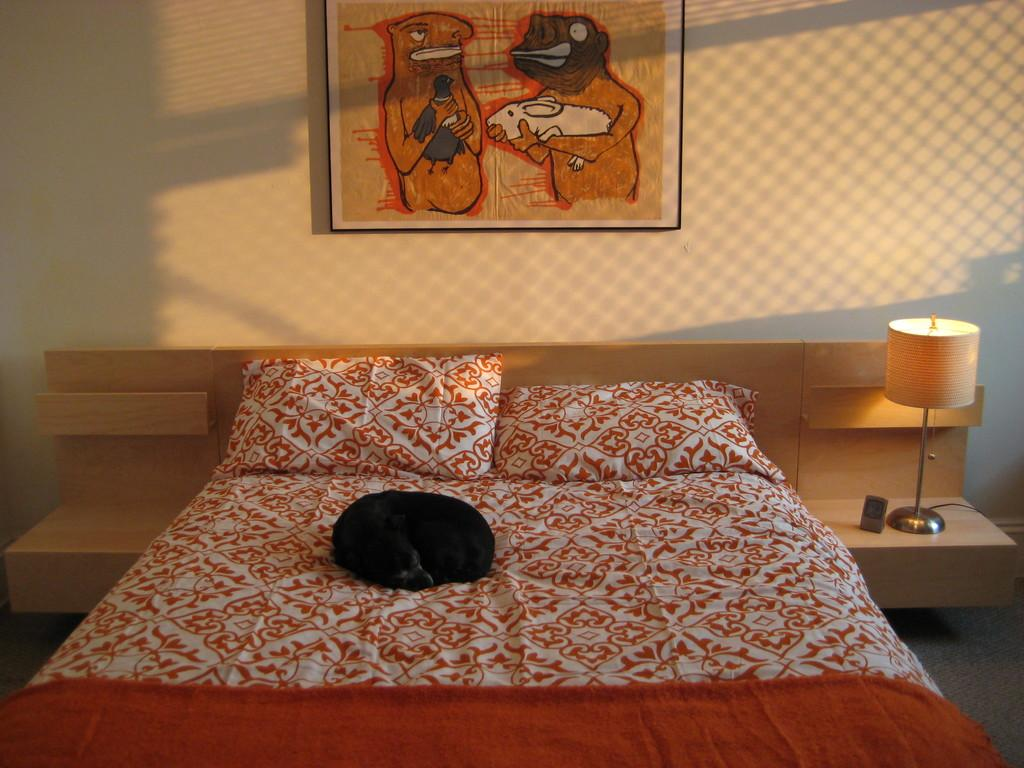What type of furniture is present in the image? There is a bed in the image. What can be found on the bed? There are pillows on the bed. What is located on a table in the image? There is a lamp on a table. What decorative item is present on the wall? There is a painting on the wall. What type of feast is being prepared on the bed in the image? There is no feast being prepared in the image; it features a bed with pillows, a lamp on a table, and a painting on the wall. 